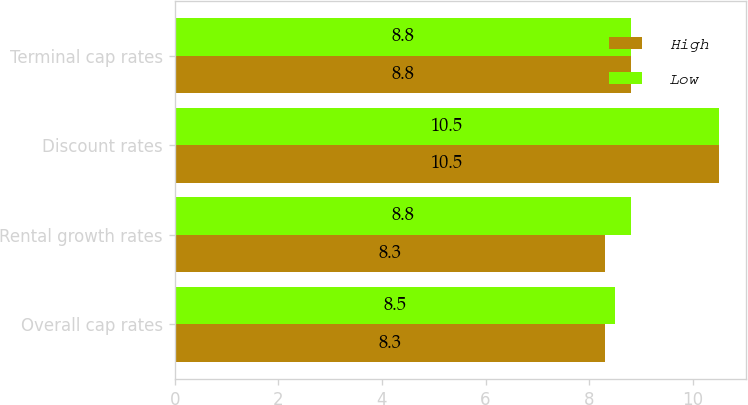Convert chart to OTSL. <chart><loc_0><loc_0><loc_500><loc_500><stacked_bar_chart><ecel><fcel>Overall cap rates<fcel>Rental growth rates<fcel>Discount rates<fcel>Terminal cap rates<nl><fcel>High<fcel>8.3<fcel>8.3<fcel>10.5<fcel>8.8<nl><fcel>Low<fcel>8.5<fcel>8.8<fcel>10.5<fcel>8.8<nl></chart> 